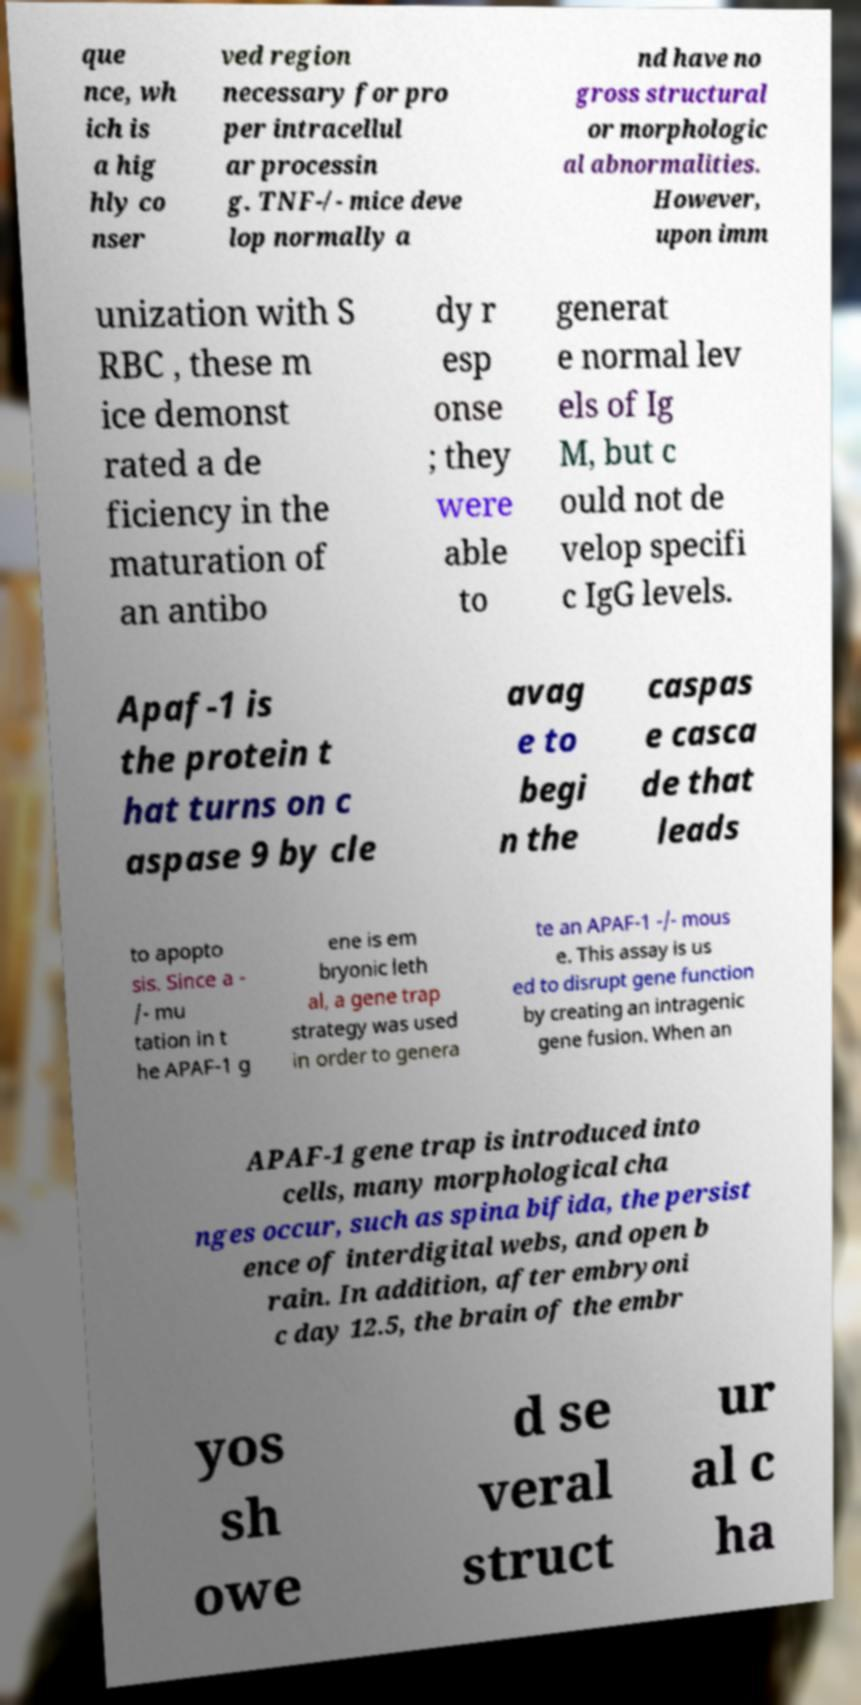Could you assist in decoding the text presented in this image and type it out clearly? que nce, wh ich is a hig hly co nser ved region necessary for pro per intracellul ar processin g. TNF-/- mice deve lop normally a nd have no gross structural or morphologic al abnormalities. However, upon imm unization with S RBC , these m ice demonst rated a de ficiency in the maturation of an antibo dy r esp onse ; they were able to generat e normal lev els of Ig M, but c ould not de velop specifi c IgG levels. Apaf-1 is the protein t hat turns on c aspase 9 by cle avag e to begi n the caspas e casca de that leads to apopto sis. Since a - /- mu tation in t he APAF-1 g ene is em bryonic leth al, a gene trap strategy was used in order to genera te an APAF-1 -/- mous e. This assay is us ed to disrupt gene function by creating an intragenic gene fusion. When an APAF-1 gene trap is introduced into cells, many morphological cha nges occur, such as spina bifida, the persist ence of interdigital webs, and open b rain. In addition, after embryoni c day 12.5, the brain of the embr yos sh owe d se veral struct ur al c ha 